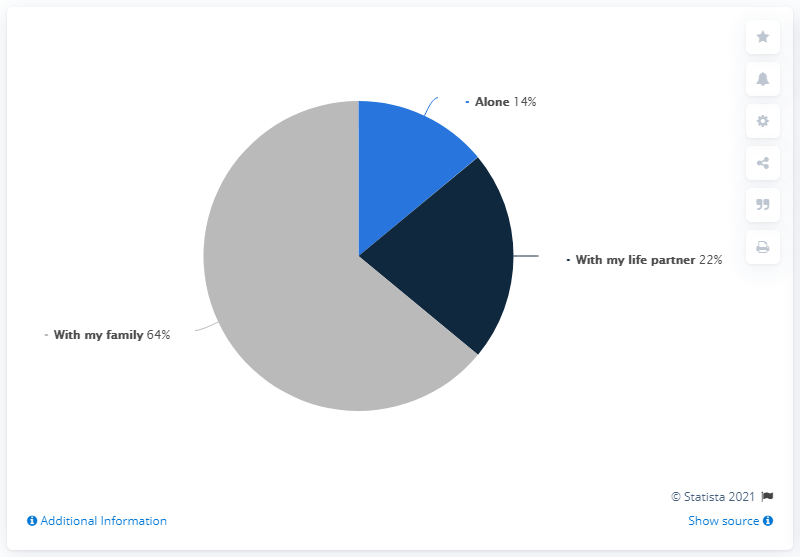Highlight a few significant elements in this photo. It is estimated that 86% of people did not spend any time alone. It is reported that 14 individuals spent time alone. 